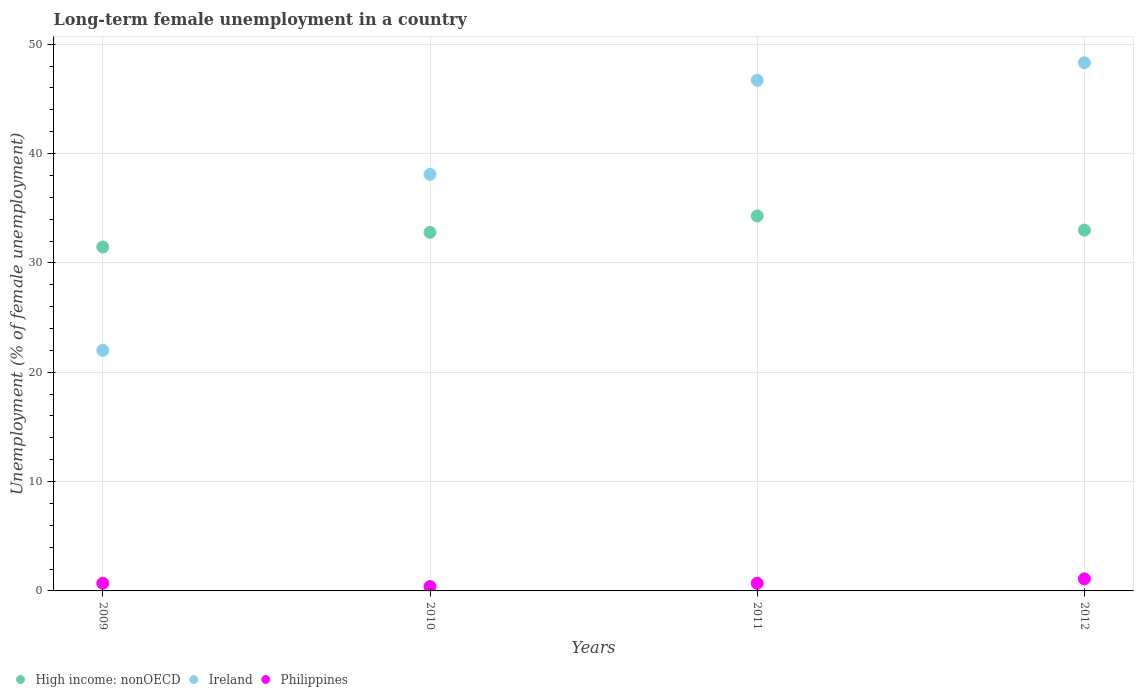What is the percentage of long-term unemployed female population in Ireland in 2010?
Ensure brevity in your answer.  38.1. Across all years, what is the maximum percentage of long-term unemployed female population in Philippines?
Make the answer very short. 1.1. Across all years, what is the minimum percentage of long-term unemployed female population in High income: nonOECD?
Make the answer very short. 31.45. In which year was the percentage of long-term unemployed female population in Philippines maximum?
Provide a short and direct response. 2012. What is the total percentage of long-term unemployed female population in Ireland in the graph?
Give a very brief answer. 155.1. What is the difference between the percentage of long-term unemployed female population in Ireland in 2009 and that in 2010?
Your response must be concise. -16.1. What is the difference between the percentage of long-term unemployed female population in Ireland in 2009 and the percentage of long-term unemployed female population in High income: nonOECD in 2012?
Make the answer very short. -10.99. What is the average percentage of long-term unemployed female population in Philippines per year?
Make the answer very short. 0.73. In the year 2011, what is the difference between the percentage of long-term unemployed female population in Philippines and percentage of long-term unemployed female population in Ireland?
Make the answer very short. -46. What is the ratio of the percentage of long-term unemployed female population in High income: nonOECD in 2009 to that in 2010?
Ensure brevity in your answer.  0.96. Is the percentage of long-term unemployed female population in Philippines in 2009 less than that in 2010?
Your answer should be compact. No. Is the difference between the percentage of long-term unemployed female population in Philippines in 2011 and 2012 greater than the difference between the percentage of long-term unemployed female population in Ireland in 2011 and 2012?
Your answer should be very brief. Yes. What is the difference between the highest and the second highest percentage of long-term unemployed female population in Philippines?
Your response must be concise. 0.4. What is the difference between the highest and the lowest percentage of long-term unemployed female population in Philippines?
Provide a short and direct response. 0.7. In how many years, is the percentage of long-term unemployed female population in Ireland greater than the average percentage of long-term unemployed female population in Ireland taken over all years?
Your answer should be compact. 2. Is the sum of the percentage of long-term unemployed female population in Philippines in 2009 and 2010 greater than the maximum percentage of long-term unemployed female population in Ireland across all years?
Your response must be concise. No. Is the percentage of long-term unemployed female population in Ireland strictly less than the percentage of long-term unemployed female population in Philippines over the years?
Keep it short and to the point. No. What is the difference between two consecutive major ticks on the Y-axis?
Your response must be concise. 10. Are the values on the major ticks of Y-axis written in scientific E-notation?
Your response must be concise. No. Does the graph contain any zero values?
Offer a terse response. No. Where does the legend appear in the graph?
Your response must be concise. Bottom left. What is the title of the graph?
Provide a short and direct response. Long-term female unemployment in a country. What is the label or title of the X-axis?
Provide a succinct answer. Years. What is the label or title of the Y-axis?
Give a very brief answer. Unemployment (% of female unemployment). What is the Unemployment (% of female unemployment) of High income: nonOECD in 2009?
Offer a terse response. 31.45. What is the Unemployment (% of female unemployment) of Philippines in 2009?
Your answer should be compact. 0.7. What is the Unemployment (% of female unemployment) of High income: nonOECD in 2010?
Ensure brevity in your answer.  32.79. What is the Unemployment (% of female unemployment) in Ireland in 2010?
Give a very brief answer. 38.1. What is the Unemployment (% of female unemployment) of Philippines in 2010?
Offer a terse response. 0.4. What is the Unemployment (% of female unemployment) of High income: nonOECD in 2011?
Your answer should be very brief. 34.29. What is the Unemployment (% of female unemployment) in Ireland in 2011?
Offer a very short reply. 46.7. What is the Unemployment (% of female unemployment) in Philippines in 2011?
Give a very brief answer. 0.7. What is the Unemployment (% of female unemployment) of High income: nonOECD in 2012?
Give a very brief answer. 32.99. What is the Unemployment (% of female unemployment) in Ireland in 2012?
Your answer should be compact. 48.3. What is the Unemployment (% of female unemployment) of Philippines in 2012?
Provide a short and direct response. 1.1. Across all years, what is the maximum Unemployment (% of female unemployment) in High income: nonOECD?
Give a very brief answer. 34.29. Across all years, what is the maximum Unemployment (% of female unemployment) of Ireland?
Make the answer very short. 48.3. Across all years, what is the maximum Unemployment (% of female unemployment) in Philippines?
Provide a short and direct response. 1.1. Across all years, what is the minimum Unemployment (% of female unemployment) of High income: nonOECD?
Your answer should be very brief. 31.45. Across all years, what is the minimum Unemployment (% of female unemployment) of Ireland?
Your response must be concise. 22. Across all years, what is the minimum Unemployment (% of female unemployment) of Philippines?
Make the answer very short. 0.4. What is the total Unemployment (% of female unemployment) in High income: nonOECD in the graph?
Make the answer very short. 131.53. What is the total Unemployment (% of female unemployment) of Ireland in the graph?
Your answer should be compact. 155.1. What is the difference between the Unemployment (% of female unemployment) in High income: nonOECD in 2009 and that in 2010?
Provide a short and direct response. -1.34. What is the difference between the Unemployment (% of female unemployment) of Ireland in 2009 and that in 2010?
Provide a succinct answer. -16.1. What is the difference between the Unemployment (% of female unemployment) of Philippines in 2009 and that in 2010?
Offer a terse response. 0.3. What is the difference between the Unemployment (% of female unemployment) of High income: nonOECD in 2009 and that in 2011?
Your response must be concise. -2.84. What is the difference between the Unemployment (% of female unemployment) of Ireland in 2009 and that in 2011?
Give a very brief answer. -24.7. What is the difference between the Unemployment (% of female unemployment) in Philippines in 2009 and that in 2011?
Ensure brevity in your answer.  0. What is the difference between the Unemployment (% of female unemployment) in High income: nonOECD in 2009 and that in 2012?
Your answer should be compact. -1.54. What is the difference between the Unemployment (% of female unemployment) of Ireland in 2009 and that in 2012?
Offer a terse response. -26.3. What is the difference between the Unemployment (% of female unemployment) of Philippines in 2009 and that in 2012?
Ensure brevity in your answer.  -0.4. What is the difference between the Unemployment (% of female unemployment) in High income: nonOECD in 2010 and that in 2011?
Your answer should be very brief. -1.5. What is the difference between the Unemployment (% of female unemployment) in Ireland in 2010 and that in 2011?
Give a very brief answer. -8.6. What is the difference between the Unemployment (% of female unemployment) in Philippines in 2010 and that in 2011?
Ensure brevity in your answer.  -0.3. What is the difference between the Unemployment (% of female unemployment) of High income: nonOECD in 2010 and that in 2012?
Your answer should be compact. -0.2. What is the difference between the Unemployment (% of female unemployment) of High income: nonOECD in 2011 and that in 2012?
Offer a terse response. 1.3. What is the difference between the Unemployment (% of female unemployment) of Ireland in 2011 and that in 2012?
Provide a short and direct response. -1.6. What is the difference between the Unemployment (% of female unemployment) of High income: nonOECD in 2009 and the Unemployment (% of female unemployment) of Ireland in 2010?
Make the answer very short. -6.65. What is the difference between the Unemployment (% of female unemployment) of High income: nonOECD in 2009 and the Unemployment (% of female unemployment) of Philippines in 2010?
Make the answer very short. 31.05. What is the difference between the Unemployment (% of female unemployment) in Ireland in 2009 and the Unemployment (% of female unemployment) in Philippines in 2010?
Give a very brief answer. 21.6. What is the difference between the Unemployment (% of female unemployment) in High income: nonOECD in 2009 and the Unemployment (% of female unemployment) in Ireland in 2011?
Keep it short and to the point. -15.25. What is the difference between the Unemployment (% of female unemployment) in High income: nonOECD in 2009 and the Unemployment (% of female unemployment) in Philippines in 2011?
Your response must be concise. 30.75. What is the difference between the Unemployment (% of female unemployment) in Ireland in 2009 and the Unemployment (% of female unemployment) in Philippines in 2011?
Make the answer very short. 21.3. What is the difference between the Unemployment (% of female unemployment) in High income: nonOECD in 2009 and the Unemployment (% of female unemployment) in Ireland in 2012?
Offer a very short reply. -16.85. What is the difference between the Unemployment (% of female unemployment) in High income: nonOECD in 2009 and the Unemployment (% of female unemployment) in Philippines in 2012?
Offer a terse response. 30.35. What is the difference between the Unemployment (% of female unemployment) of Ireland in 2009 and the Unemployment (% of female unemployment) of Philippines in 2012?
Provide a succinct answer. 20.9. What is the difference between the Unemployment (% of female unemployment) of High income: nonOECD in 2010 and the Unemployment (% of female unemployment) of Ireland in 2011?
Offer a very short reply. -13.91. What is the difference between the Unemployment (% of female unemployment) of High income: nonOECD in 2010 and the Unemployment (% of female unemployment) of Philippines in 2011?
Your answer should be compact. 32.09. What is the difference between the Unemployment (% of female unemployment) of Ireland in 2010 and the Unemployment (% of female unemployment) of Philippines in 2011?
Your answer should be very brief. 37.4. What is the difference between the Unemployment (% of female unemployment) of High income: nonOECD in 2010 and the Unemployment (% of female unemployment) of Ireland in 2012?
Offer a very short reply. -15.51. What is the difference between the Unemployment (% of female unemployment) of High income: nonOECD in 2010 and the Unemployment (% of female unemployment) of Philippines in 2012?
Make the answer very short. 31.69. What is the difference between the Unemployment (% of female unemployment) in High income: nonOECD in 2011 and the Unemployment (% of female unemployment) in Ireland in 2012?
Ensure brevity in your answer.  -14.01. What is the difference between the Unemployment (% of female unemployment) in High income: nonOECD in 2011 and the Unemployment (% of female unemployment) in Philippines in 2012?
Ensure brevity in your answer.  33.19. What is the difference between the Unemployment (% of female unemployment) in Ireland in 2011 and the Unemployment (% of female unemployment) in Philippines in 2012?
Keep it short and to the point. 45.6. What is the average Unemployment (% of female unemployment) of High income: nonOECD per year?
Provide a short and direct response. 32.88. What is the average Unemployment (% of female unemployment) in Ireland per year?
Your response must be concise. 38.77. What is the average Unemployment (% of female unemployment) of Philippines per year?
Provide a succinct answer. 0.72. In the year 2009, what is the difference between the Unemployment (% of female unemployment) in High income: nonOECD and Unemployment (% of female unemployment) in Ireland?
Your answer should be very brief. 9.45. In the year 2009, what is the difference between the Unemployment (% of female unemployment) of High income: nonOECD and Unemployment (% of female unemployment) of Philippines?
Your answer should be compact. 30.75. In the year 2009, what is the difference between the Unemployment (% of female unemployment) of Ireland and Unemployment (% of female unemployment) of Philippines?
Offer a very short reply. 21.3. In the year 2010, what is the difference between the Unemployment (% of female unemployment) of High income: nonOECD and Unemployment (% of female unemployment) of Ireland?
Your response must be concise. -5.31. In the year 2010, what is the difference between the Unemployment (% of female unemployment) of High income: nonOECD and Unemployment (% of female unemployment) of Philippines?
Give a very brief answer. 32.39. In the year 2010, what is the difference between the Unemployment (% of female unemployment) in Ireland and Unemployment (% of female unemployment) in Philippines?
Offer a very short reply. 37.7. In the year 2011, what is the difference between the Unemployment (% of female unemployment) in High income: nonOECD and Unemployment (% of female unemployment) in Ireland?
Provide a succinct answer. -12.41. In the year 2011, what is the difference between the Unemployment (% of female unemployment) in High income: nonOECD and Unemployment (% of female unemployment) in Philippines?
Make the answer very short. 33.59. In the year 2011, what is the difference between the Unemployment (% of female unemployment) of Ireland and Unemployment (% of female unemployment) of Philippines?
Your response must be concise. 46. In the year 2012, what is the difference between the Unemployment (% of female unemployment) of High income: nonOECD and Unemployment (% of female unemployment) of Ireland?
Provide a succinct answer. -15.31. In the year 2012, what is the difference between the Unemployment (% of female unemployment) of High income: nonOECD and Unemployment (% of female unemployment) of Philippines?
Your answer should be compact. 31.89. In the year 2012, what is the difference between the Unemployment (% of female unemployment) of Ireland and Unemployment (% of female unemployment) of Philippines?
Ensure brevity in your answer.  47.2. What is the ratio of the Unemployment (% of female unemployment) of High income: nonOECD in 2009 to that in 2010?
Ensure brevity in your answer.  0.96. What is the ratio of the Unemployment (% of female unemployment) in Ireland in 2009 to that in 2010?
Ensure brevity in your answer.  0.58. What is the ratio of the Unemployment (% of female unemployment) in High income: nonOECD in 2009 to that in 2011?
Give a very brief answer. 0.92. What is the ratio of the Unemployment (% of female unemployment) in Ireland in 2009 to that in 2011?
Your answer should be very brief. 0.47. What is the ratio of the Unemployment (% of female unemployment) of High income: nonOECD in 2009 to that in 2012?
Provide a succinct answer. 0.95. What is the ratio of the Unemployment (% of female unemployment) in Ireland in 2009 to that in 2012?
Provide a short and direct response. 0.46. What is the ratio of the Unemployment (% of female unemployment) of Philippines in 2009 to that in 2012?
Give a very brief answer. 0.64. What is the ratio of the Unemployment (% of female unemployment) of High income: nonOECD in 2010 to that in 2011?
Your answer should be compact. 0.96. What is the ratio of the Unemployment (% of female unemployment) of Ireland in 2010 to that in 2011?
Make the answer very short. 0.82. What is the ratio of the Unemployment (% of female unemployment) of Ireland in 2010 to that in 2012?
Provide a succinct answer. 0.79. What is the ratio of the Unemployment (% of female unemployment) in Philippines in 2010 to that in 2012?
Keep it short and to the point. 0.36. What is the ratio of the Unemployment (% of female unemployment) of High income: nonOECD in 2011 to that in 2012?
Offer a terse response. 1.04. What is the ratio of the Unemployment (% of female unemployment) in Ireland in 2011 to that in 2012?
Offer a terse response. 0.97. What is the ratio of the Unemployment (% of female unemployment) of Philippines in 2011 to that in 2012?
Provide a short and direct response. 0.64. What is the difference between the highest and the second highest Unemployment (% of female unemployment) of High income: nonOECD?
Keep it short and to the point. 1.3. What is the difference between the highest and the second highest Unemployment (% of female unemployment) in Philippines?
Offer a very short reply. 0.4. What is the difference between the highest and the lowest Unemployment (% of female unemployment) in High income: nonOECD?
Make the answer very short. 2.84. What is the difference between the highest and the lowest Unemployment (% of female unemployment) of Ireland?
Your answer should be very brief. 26.3. What is the difference between the highest and the lowest Unemployment (% of female unemployment) of Philippines?
Give a very brief answer. 0.7. 